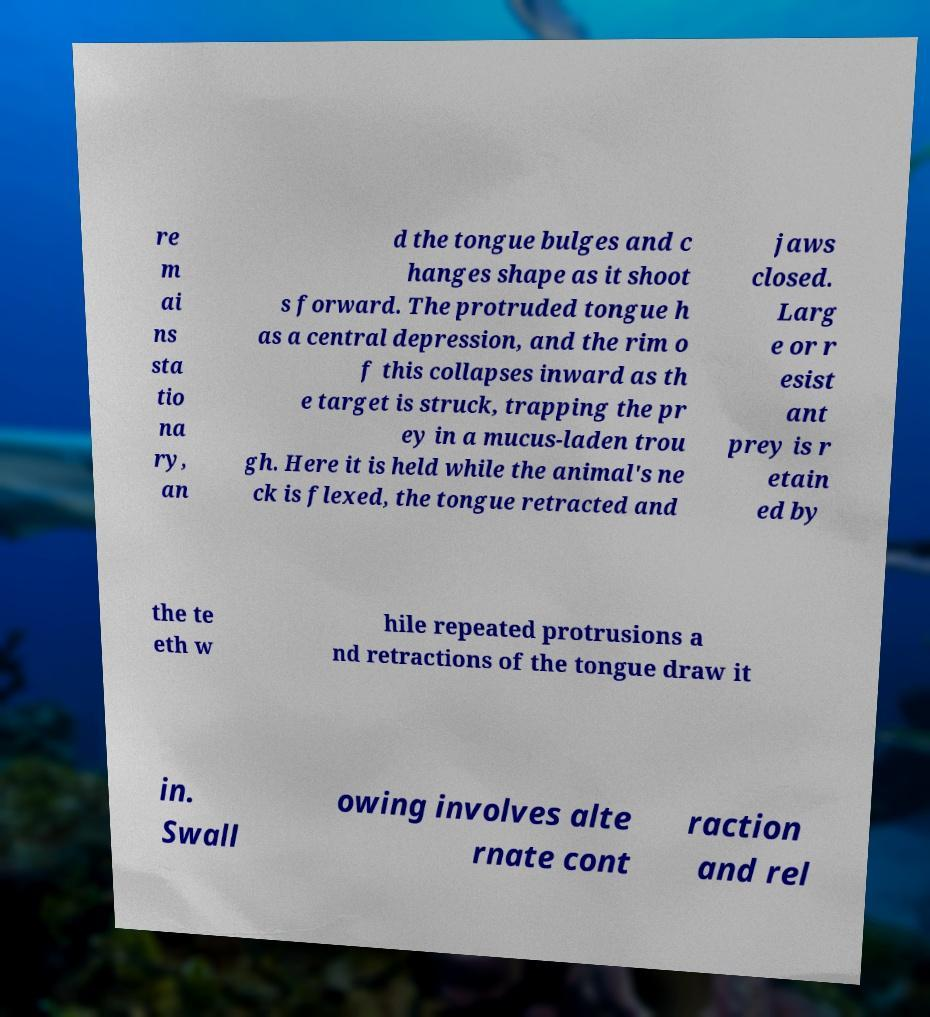For documentation purposes, I need the text within this image transcribed. Could you provide that? re m ai ns sta tio na ry, an d the tongue bulges and c hanges shape as it shoot s forward. The protruded tongue h as a central depression, and the rim o f this collapses inward as th e target is struck, trapping the pr ey in a mucus-laden trou gh. Here it is held while the animal's ne ck is flexed, the tongue retracted and jaws closed. Larg e or r esist ant prey is r etain ed by the te eth w hile repeated protrusions a nd retractions of the tongue draw it in. Swall owing involves alte rnate cont raction and rel 